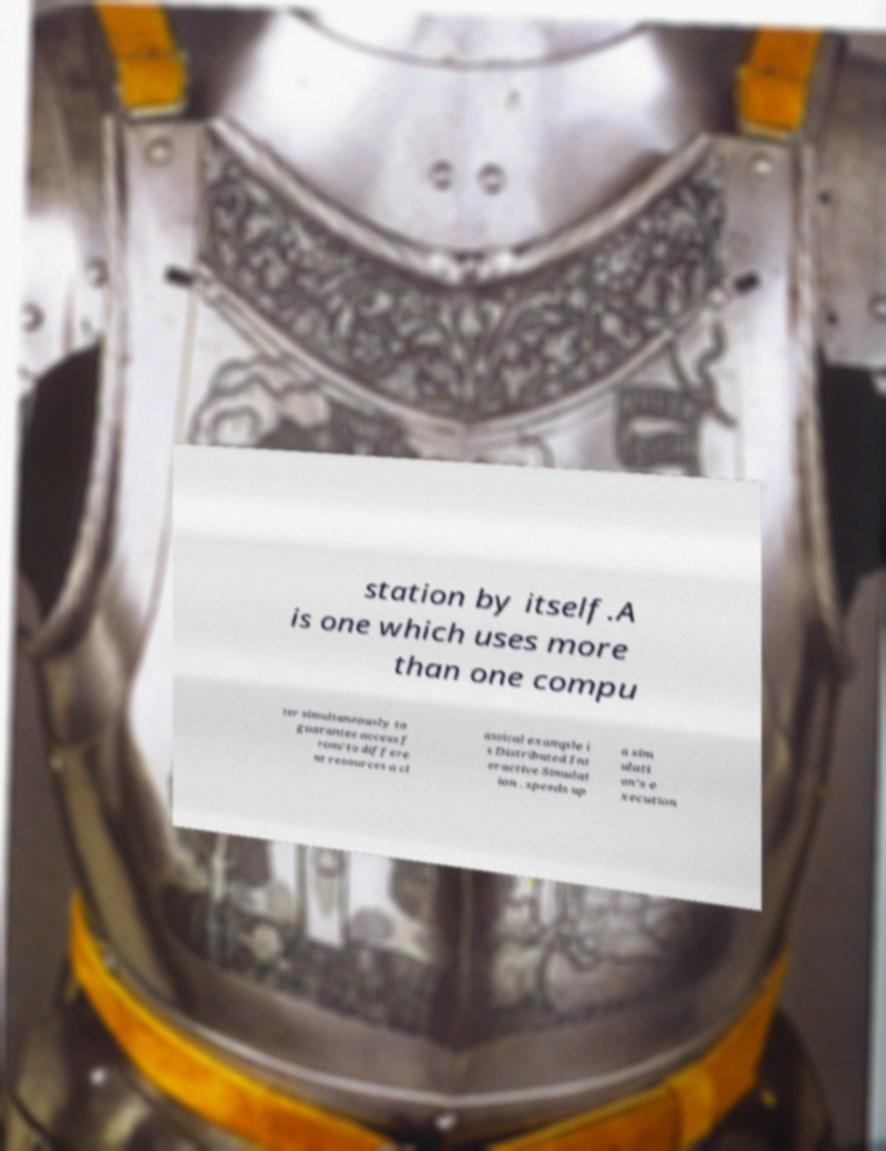I need the written content from this picture converted into text. Can you do that? station by itself.A is one which uses more than one compu ter simultaneously to guarantee access f rom/to differe nt resources a cl assical example i s Distributed Int eractive Simulat ion . speeds up a sim ulati on's e xecution 